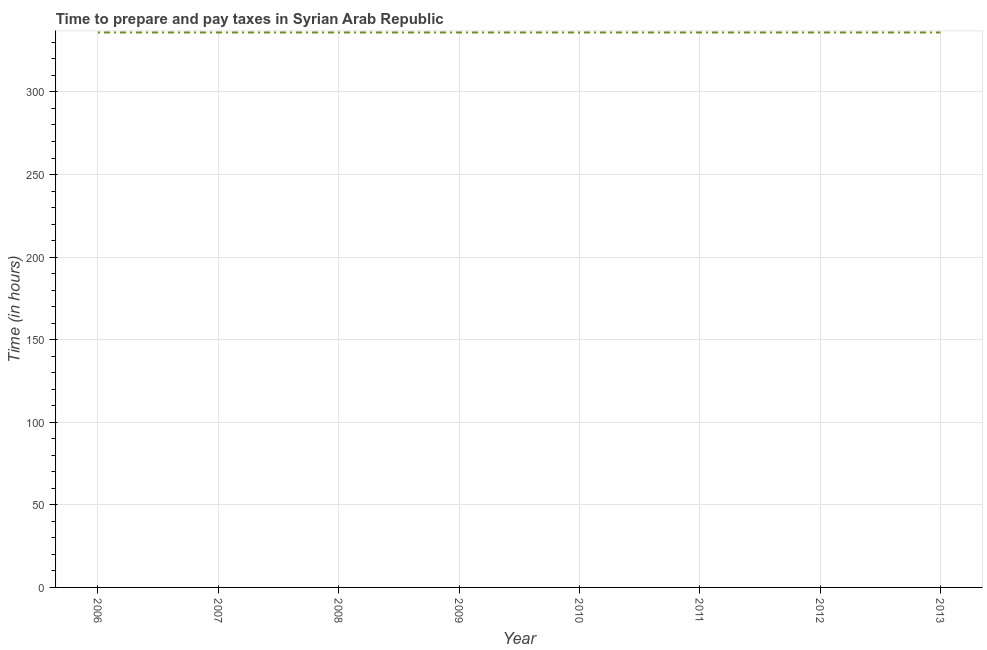What is the time to prepare and pay taxes in 2011?
Keep it short and to the point. 336. Across all years, what is the maximum time to prepare and pay taxes?
Keep it short and to the point. 336. Across all years, what is the minimum time to prepare and pay taxes?
Make the answer very short. 336. In which year was the time to prepare and pay taxes maximum?
Ensure brevity in your answer.  2006. In which year was the time to prepare and pay taxes minimum?
Give a very brief answer. 2006. What is the sum of the time to prepare and pay taxes?
Your response must be concise. 2688. What is the average time to prepare and pay taxes per year?
Provide a succinct answer. 336. What is the median time to prepare and pay taxes?
Provide a short and direct response. 336. What is the ratio of the time to prepare and pay taxes in 2007 to that in 2011?
Your response must be concise. 1. Is the time to prepare and pay taxes in 2006 less than that in 2008?
Offer a very short reply. No. Is the difference between the time to prepare and pay taxes in 2009 and 2013 greater than the difference between any two years?
Give a very brief answer. Yes. What is the difference between the highest and the second highest time to prepare and pay taxes?
Your response must be concise. 0. What is the difference between the highest and the lowest time to prepare and pay taxes?
Offer a terse response. 0. In how many years, is the time to prepare and pay taxes greater than the average time to prepare and pay taxes taken over all years?
Ensure brevity in your answer.  0. How many years are there in the graph?
Offer a terse response. 8. Are the values on the major ticks of Y-axis written in scientific E-notation?
Provide a succinct answer. No. Does the graph contain any zero values?
Give a very brief answer. No. Does the graph contain grids?
Provide a short and direct response. Yes. What is the title of the graph?
Provide a short and direct response. Time to prepare and pay taxes in Syrian Arab Republic. What is the label or title of the Y-axis?
Ensure brevity in your answer.  Time (in hours). What is the Time (in hours) of 2006?
Your answer should be very brief. 336. What is the Time (in hours) in 2007?
Ensure brevity in your answer.  336. What is the Time (in hours) in 2008?
Provide a succinct answer. 336. What is the Time (in hours) of 2009?
Make the answer very short. 336. What is the Time (in hours) in 2010?
Offer a terse response. 336. What is the Time (in hours) in 2011?
Your answer should be very brief. 336. What is the Time (in hours) of 2012?
Give a very brief answer. 336. What is the Time (in hours) of 2013?
Keep it short and to the point. 336. What is the difference between the Time (in hours) in 2006 and 2007?
Offer a terse response. 0. What is the difference between the Time (in hours) in 2006 and 2008?
Your response must be concise. 0. What is the difference between the Time (in hours) in 2006 and 2013?
Offer a terse response. 0. What is the difference between the Time (in hours) in 2007 and 2008?
Your response must be concise. 0. What is the difference between the Time (in hours) in 2007 and 2011?
Provide a short and direct response. 0. What is the difference between the Time (in hours) in 2007 and 2012?
Your answer should be very brief. 0. What is the difference between the Time (in hours) in 2008 and 2009?
Give a very brief answer. 0. What is the difference between the Time (in hours) in 2008 and 2011?
Make the answer very short. 0. What is the difference between the Time (in hours) in 2008 and 2012?
Ensure brevity in your answer.  0. What is the difference between the Time (in hours) in 2008 and 2013?
Your answer should be very brief. 0. What is the difference between the Time (in hours) in 2009 and 2012?
Provide a short and direct response. 0. What is the difference between the Time (in hours) in 2011 and 2012?
Offer a terse response. 0. What is the difference between the Time (in hours) in 2011 and 2013?
Your response must be concise. 0. What is the difference between the Time (in hours) in 2012 and 2013?
Offer a terse response. 0. What is the ratio of the Time (in hours) in 2006 to that in 2007?
Your answer should be very brief. 1. What is the ratio of the Time (in hours) in 2006 to that in 2010?
Your answer should be compact. 1. What is the ratio of the Time (in hours) in 2006 to that in 2011?
Your answer should be compact. 1. What is the ratio of the Time (in hours) in 2007 to that in 2012?
Your answer should be compact. 1. What is the ratio of the Time (in hours) in 2008 to that in 2009?
Provide a short and direct response. 1. What is the ratio of the Time (in hours) in 2008 to that in 2011?
Provide a short and direct response. 1. What is the ratio of the Time (in hours) in 2008 to that in 2013?
Your answer should be compact. 1. What is the ratio of the Time (in hours) in 2009 to that in 2010?
Offer a very short reply. 1. What is the ratio of the Time (in hours) in 2009 to that in 2011?
Offer a terse response. 1. What is the ratio of the Time (in hours) in 2009 to that in 2012?
Your response must be concise. 1. What is the ratio of the Time (in hours) in 2010 to that in 2011?
Give a very brief answer. 1. What is the ratio of the Time (in hours) in 2010 to that in 2012?
Provide a short and direct response. 1. What is the ratio of the Time (in hours) in 2010 to that in 2013?
Give a very brief answer. 1. What is the ratio of the Time (in hours) in 2012 to that in 2013?
Ensure brevity in your answer.  1. 